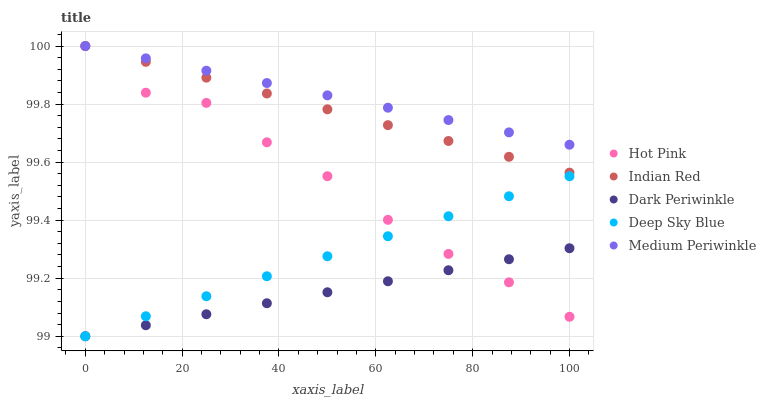Does Dark Periwinkle have the minimum area under the curve?
Answer yes or no. Yes. Does Medium Periwinkle have the maximum area under the curve?
Answer yes or no. Yes. Does Hot Pink have the minimum area under the curve?
Answer yes or no. No. Does Hot Pink have the maximum area under the curve?
Answer yes or no. No. Is Dark Periwinkle the smoothest?
Answer yes or no. Yes. Is Hot Pink the roughest?
Answer yes or no. Yes. Is Medium Periwinkle the smoothest?
Answer yes or no. No. Is Medium Periwinkle the roughest?
Answer yes or no. No. Does Deep Sky Blue have the lowest value?
Answer yes or no. Yes. Does Hot Pink have the lowest value?
Answer yes or no. No. Does Indian Red have the highest value?
Answer yes or no. Yes. Does Dark Periwinkle have the highest value?
Answer yes or no. No. Is Deep Sky Blue less than Medium Periwinkle?
Answer yes or no. Yes. Is Indian Red greater than Dark Periwinkle?
Answer yes or no. Yes. Does Medium Periwinkle intersect Indian Red?
Answer yes or no. Yes. Is Medium Periwinkle less than Indian Red?
Answer yes or no. No. Is Medium Periwinkle greater than Indian Red?
Answer yes or no. No. Does Deep Sky Blue intersect Medium Periwinkle?
Answer yes or no. No. 